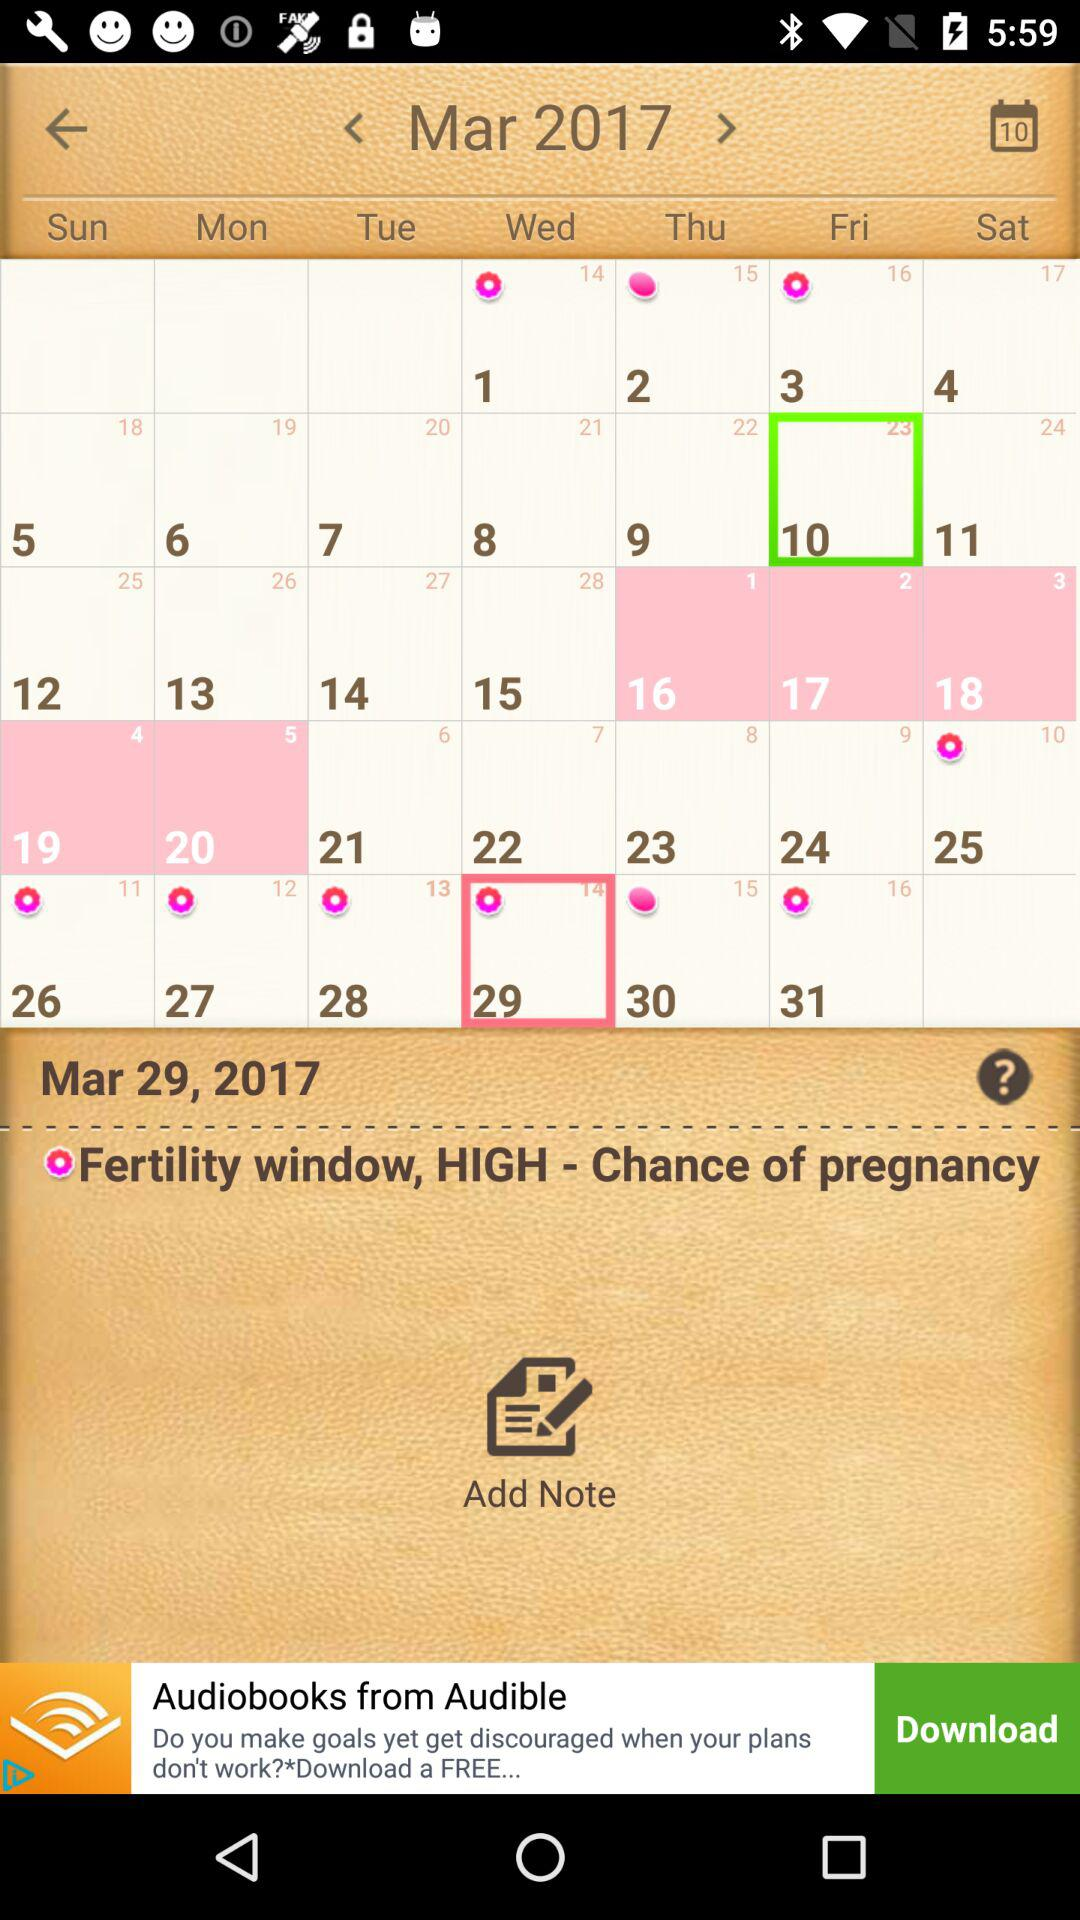What is the selected date for the fertility window with a high chance of pregnancy? The selected date for the fertility window with a high chance of pregnancy is Wednesday, March 29, 2017. 